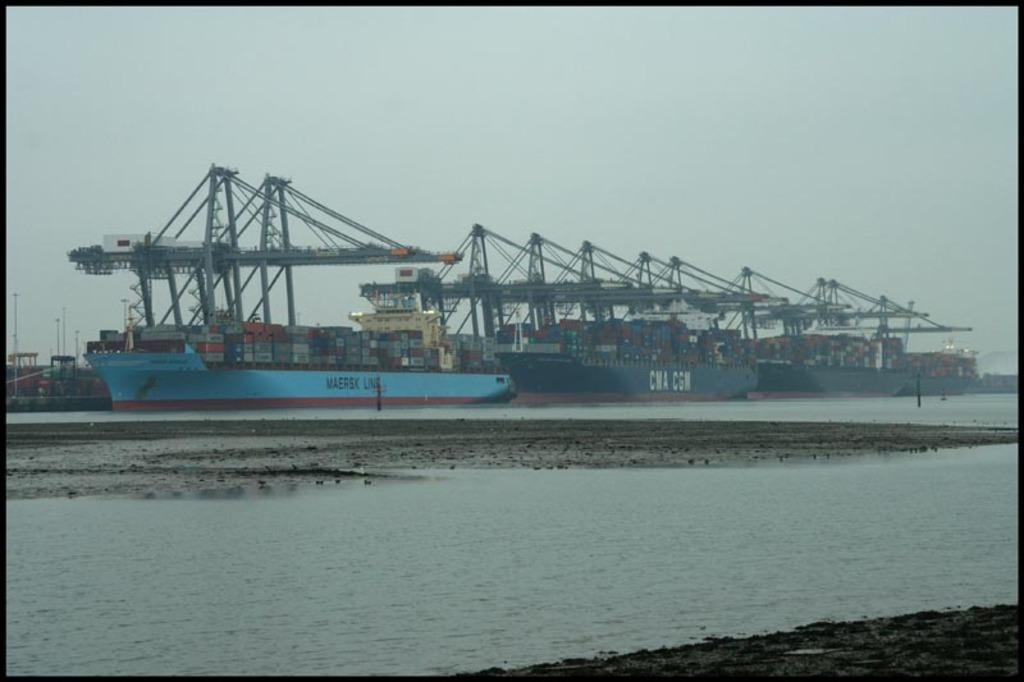What type of vehicles are in the image? There are ships in the image. Where are the ships located? The ships are on the sea. What else can be seen in the image besides the ships? There is land visible in the image. What is visible in the background of the image? The sky is visible in the background of the image. What type of calendar is hanging on the ship in the image? There is no calendar present in the image; it features ships on the sea with land and sky visible in the background. 